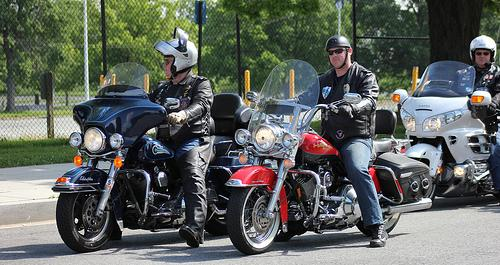List the colors of the three motorcycles in the scene. Red, white, and black. What are the trees and grass colors in the scene? Green. What color are the lights in front of the motorcyclists? Orange. Describe an attribute of the location where the image was taken. The park has a wooden sign post with a sign on it. Are riders in the image wearing helmets? If so, specify the color of a helmet in the scene. Yes, riders are wearing helmets. There is a white helmet in the scene. Mention one accessory worn by a man riding a motorcycle. Sunglasses. What is the color of the motorcyclist's helmet with the visor up? Gray. Identify the direction the motorcyclists are traveling in based on the image. Left direction. Can you describe the background behind the chain-link fence? There are yellow cement pillars and a blue parking sign. Comment on a detail of the red motorcycle. The front middle light on the red motorcycle is on. Are the trees in the background brown? This instruction is misleading as it suggests the trees are brown when the given information mentions that the trees are green. Can you identify the purple motorcycle in the image? This instruction is misleading because there is no purple motorcycle in the image according to the given information. There are red, white, and black motorcycles. Are there any yellow lights on the red motorcycle? This instruction is misleading as there are no yellow lights mentioned on the red motorcycle. Is the man on the white motorcycle wearing a blue helmet? The instruction is misleading because the man on the white motorcycle is wearing a white helmet, not a blue one. Is the grass in the image purple? This instruction is misleading because it suggests the grass is purple when the given information states that the grass is green. Does the man on the black motorcycle have a green helmet? The instruction is misleading because the man on the black motorcycle has a gray helmet, not a green one. 